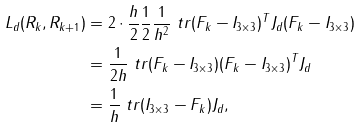Convert formula to latex. <formula><loc_0><loc_0><loc_500><loc_500>L _ { d } ( R _ { k } , R _ { k + 1 } ) & = 2 \cdot \frac { h } { 2 } \frac { 1 } { 2 } \frac { 1 } { h ^ { 2 } } \ t r { ( F _ { k } - I _ { 3 \times 3 } ) ^ { T } J _ { d } ( F _ { k } - I _ { 3 \times 3 } ) } \\ & = \frac { 1 } { 2 h } \ t r { ( F _ { k } - I _ { 3 \times 3 } ) ( F _ { k } - I _ { 3 \times 3 } ) ^ { T } J _ { d } } \\ & = \frac { 1 } { h } \ t r { ( I _ { 3 \times 3 } - F _ { k } ) J _ { d } } ,</formula> 